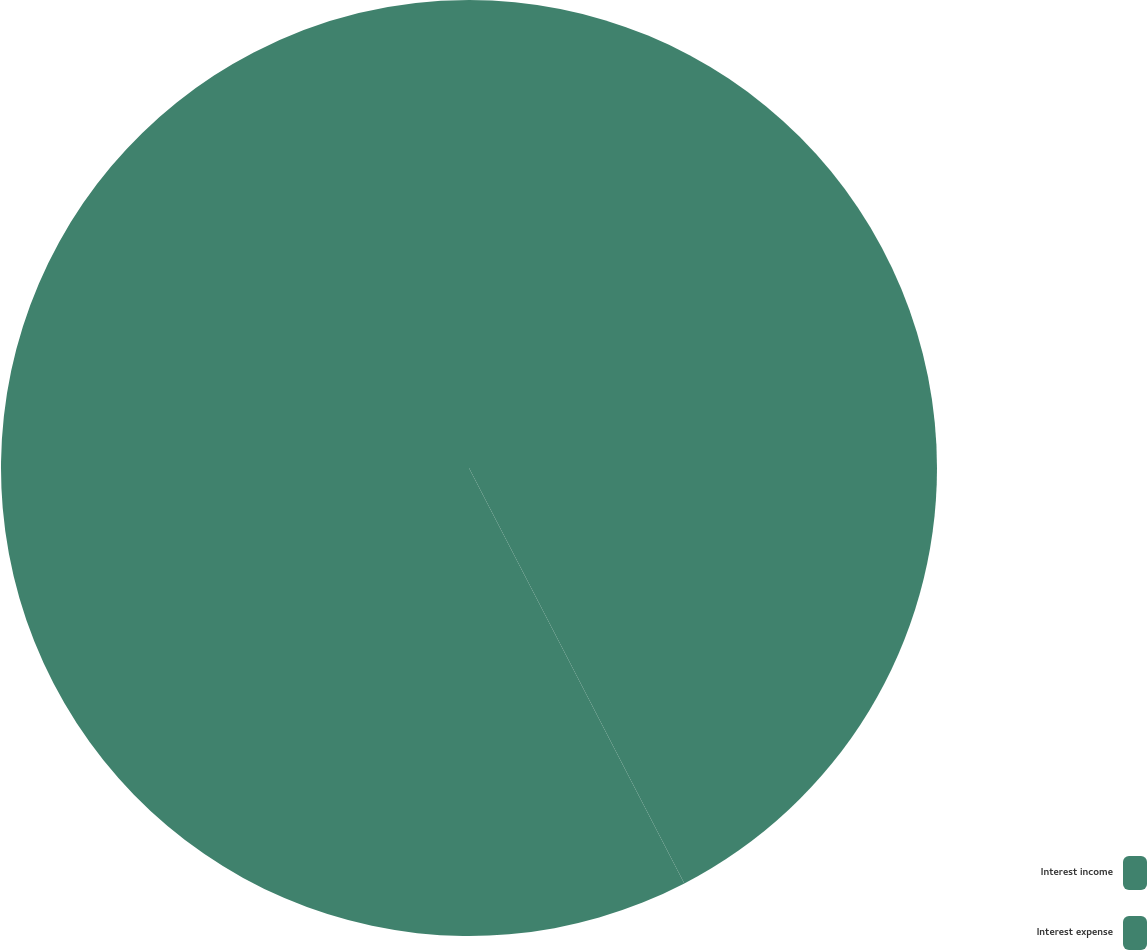Convert chart. <chart><loc_0><loc_0><loc_500><loc_500><pie_chart><fcel>Interest income<fcel>Interest expense<nl><fcel>42.39%<fcel>57.61%<nl></chart> 